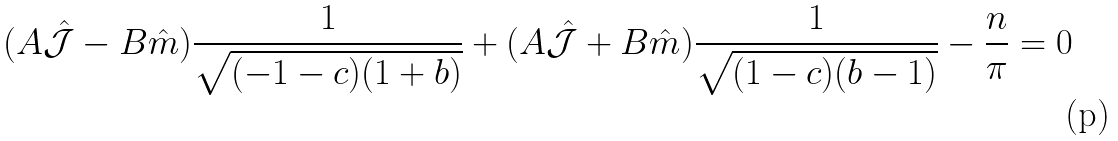Convert formula to latex. <formula><loc_0><loc_0><loc_500><loc_500>( A \hat { \mathcal { J } } - B \hat { m } ) \frac { 1 } { \sqrt { ( - 1 - c ) ( 1 + b ) } } + ( A \hat { \mathcal { J } } + B \hat { m } ) \frac { 1 } { \sqrt { ( 1 - c ) ( b - 1 ) } } - \frac { n } { \pi } = 0</formula> 